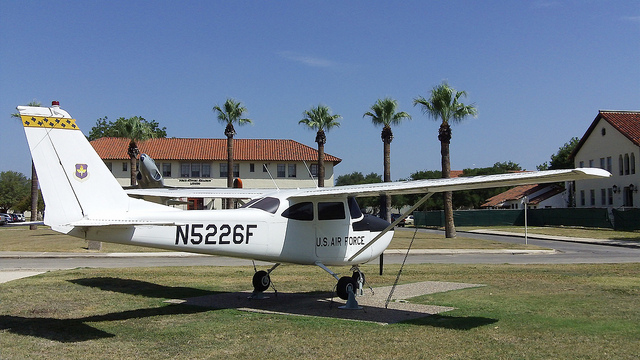Please identify all text content in this image. N5226F U S FORCE AIR 